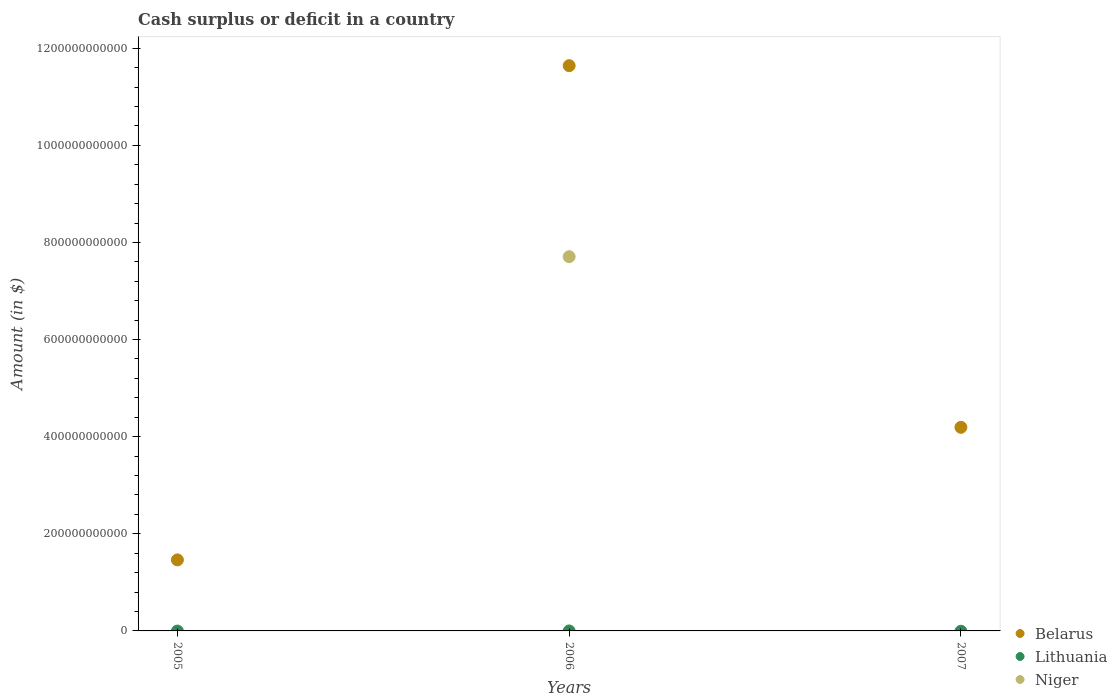How many different coloured dotlines are there?
Keep it short and to the point. 2. What is the amount of cash surplus or deficit in Belarus in 2005?
Offer a terse response. 1.46e+11. Across all years, what is the maximum amount of cash surplus or deficit in Belarus?
Keep it short and to the point. 1.16e+12. Across all years, what is the minimum amount of cash surplus or deficit in Niger?
Keep it short and to the point. 0. What is the total amount of cash surplus or deficit in Belarus in the graph?
Provide a succinct answer. 1.73e+12. What is the difference between the amount of cash surplus or deficit in Belarus in 2006 and that in 2007?
Keep it short and to the point. 7.45e+11. What is the difference between the amount of cash surplus or deficit in Belarus in 2006 and the amount of cash surplus or deficit in Niger in 2005?
Give a very brief answer. 1.16e+12. What is the average amount of cash surplus or deficit in Belarus per year?
Your response must be concise. 5.77e+11. In the year 2006, what is the difference between the amount of cash surplus or deficit in Belarus and amount of cash surplus or deficit in Niger?
Your response must be concise. 3.93e+11. What is the ratio of the amount of cash surplus or deficit in Belarus in 2005 to that in 2007?
Keep it short and to the point. 0.35. What is the difference between the highest and the second highest amount of cash surplus or deficit in Belarus?
Give a very brief answer. 7.45e+11. What is the difference between the highest and the lowest amount of cash surplus or deficit in Niger?
Your answer should be compact. 7.71e+11. Is it the case that in every year, the sum of the amount of cash surplus or deficit in Belarus and amount of cash surplus or deficit in Niger  is greater than the amount of cash surplus or deficit in Lithuania?
Your response must be concise. Yes. Is the amount of cash surplus or deficit in Lithuania strictly greater than the amount of cash surplus or deficit in Niger over the years?
Provide a succinct answer. No. How many years are there in the graph?
Provide a succinct answer. 3. What is the difference between two consecutive major ticks on the Y-axis?
Make the answer very short. 2.00e+11. Does the graph contain any zero values?
Ensure brevity in your answer.  Yes. Does the graph contain grids?
Your answer should be very brief. No. Where does the legend appear in the graph?
Provide a short and direct response. Bottom right. How are the legend labels stacked?
Keep it short and to the point. Vertical. What is the title of the graph?
Ensure brevity in your answer.  Cash surplus or deficit in a country. Does "Equatorial Guinea" appear as one of the legend labels in the graph?
Make the answer very short. No. What is the label or title of the Y-axis?
Make the answer very short. Amount (in $). What is the Amount (in $) of Belarus in 2005?
Provide a short and direct response. 1.46e+11. What is the Amount (in $) of Belarus in 2006?
Provide a succinct answer. 1.16e+12. What is the Amount (in $) in Lithuania in 2006?
Provide a succinct answer. 0. What is the Amount (in $) in Niger in 2006?
Provide a succinct answer. 7.71e+11. What is the Amount (in $) in Belarus in 2007?
Your answer should be compact. 4.19e+11. What is the Amount (in $) of Niger in 2007?
Offer a very short reply. 0. Across all years, what is the maximum Amount (in $) of Belarus?
Offer a very short reply. 1.16e+12. Across all years, what is the maximum Amount (in $) of Niger?
Your response must be concise. 7.71e+11. Across all years, what is the minimum Amount (in $) in Belarus?
Your answer should be very brief. 1.46e+11. What is the total Amount (in $) of Belarus in the graph?
Ensure brevity in your answer.  1.73e+12. What is the total Amount (in $) of Lithuania in the graph?
Offer a very short reply. 0. What is the total Amount (in $) of Niger in the graph?
Provide a succinct answer. 7.71e+11. What is the difference between the Amount (in $) of Belarus in 2005 and that in 2006?
Provide a short and direct response. -1.02e+12. What is the difference between the Amount (in $) in Belarus in 2005 and that in 2007?
Ensure brevity in your answer.  -2.73e+11. What is the difference between the Amount (in $) of Belarus in 2006 and that in 2007?
Give a very brief answer. 7.45e+11. What is the difference between the Amount (in $) of Belarus in 2005 and the Amount (in $) of Niger in 2006?
Offer a very short reply. -6.24e+11. What is the average Amount (in $) in Belarus per year?
Offer a terse response. 5.77e+11. What is the average Amount (in $) of Niger per year?
Your response must be concise. 2.57e+11. In the year 2006, what is the difference between the Amount (in $) in Belarus and Amount (in $) in Niger?
Provide a succinct answer. 3.93e+11. What is the ratio of the Amount (in $) of Belarus in 2005 to that in 2006?
Make the answer very short. 0.13. What is the ratio of the Amount (in $) in Belarus in 2005 to that in 2007?
Your answer should be very brief. 0.35. What is the ratio of the Amount (in $) in Belarus in 2006 to that in 2007?
Your answer should be compact. 2.78. What is the difference between the highest and the second highest Amount (in $) of Belarus?
Provide a succinct answer. 7.45e+11. What is the difference between the highest and the lowest Amount (in $) of Belarus?
Offer a terse response. 1.02e+12. What is the difference between the highest and the lowest Amount (in $) in Niger?
Make the answer very short. 7.71e+11. 